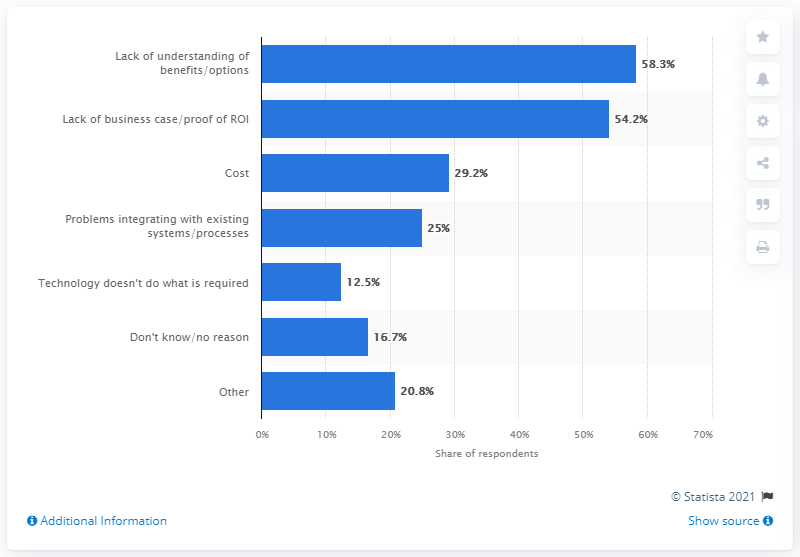List a handful of essential elements in this visual. According to the results of the survey, 58.3% of XR professionals reported that a lack of understanding for the benefits or options of virtual reality is an issue that is preventing them from integrating the technology into their work. According to the survey results, 54.2% of XR professionals cited the lack of a business case or proof of a return on investment as a challenge. According to the survey of XR professionals, 58.3% identified a lack of understanding for the benefits or options of virtual reality as an issue that is preventing them from integrating it into their work. 